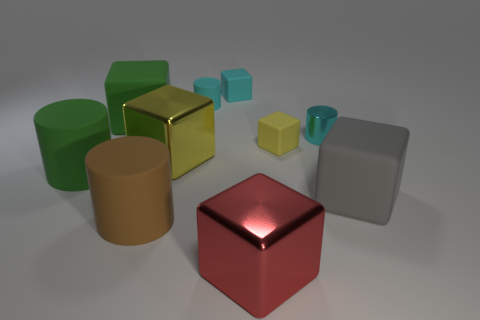There is a metal object to the left of the red object; how many large green rubber blocks are to the left of it? To the left of the red object, there is one large green rubber block situated closely by, exhibiting a matte surface and a cubic shape that contrasts with the shiny metal and rounded forms nearby. 